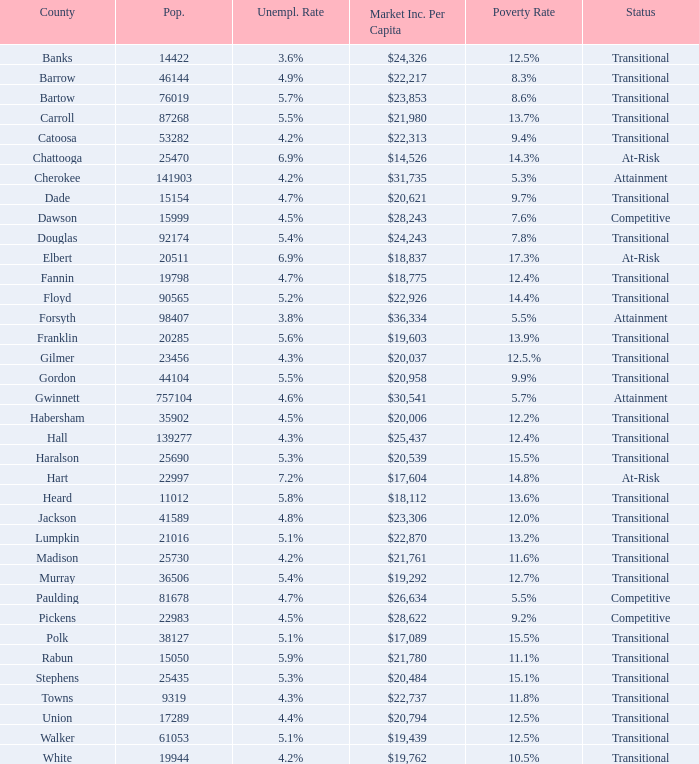6% joblessness rate? Banks. 